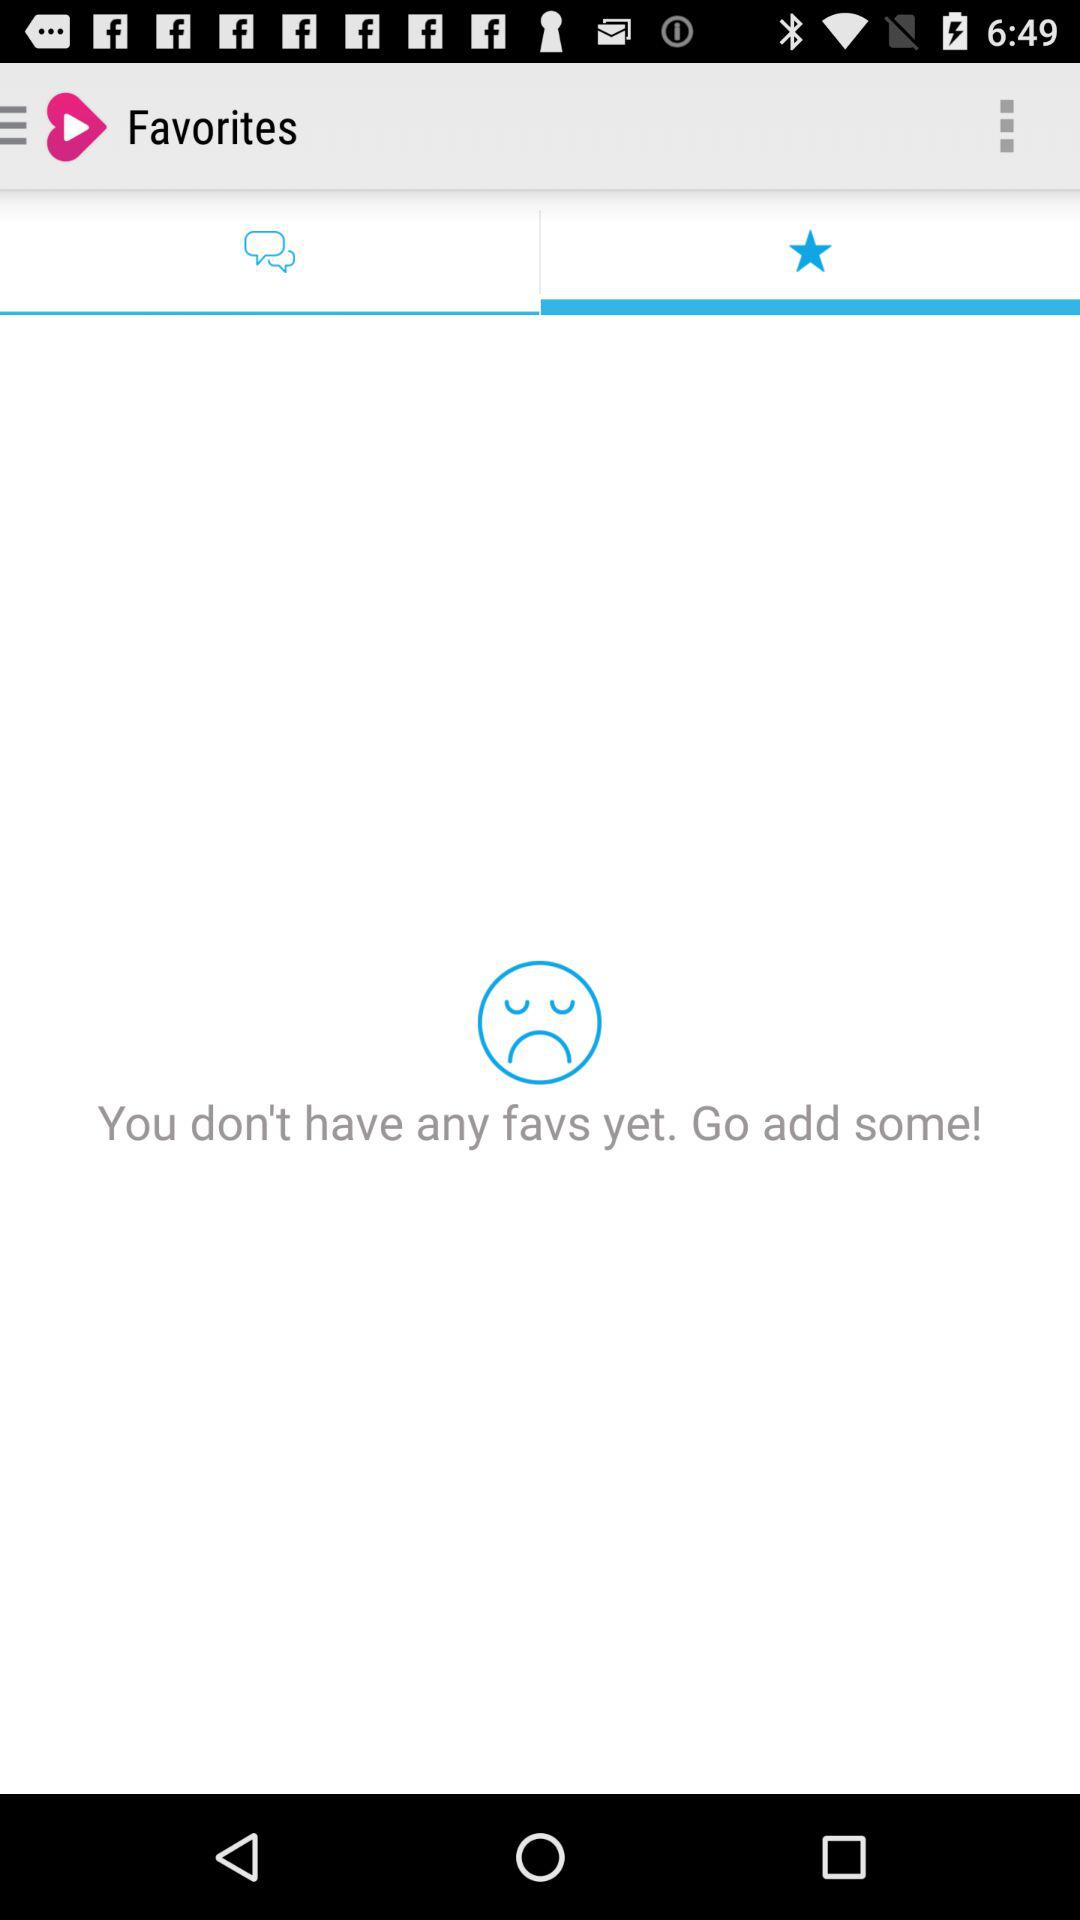Which tab is selected? The tab selected is "starrred". 